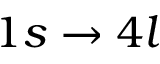<formula> <loc_0><loc_0><loc_500><loc_500>1 s \to 4 l</formula> 